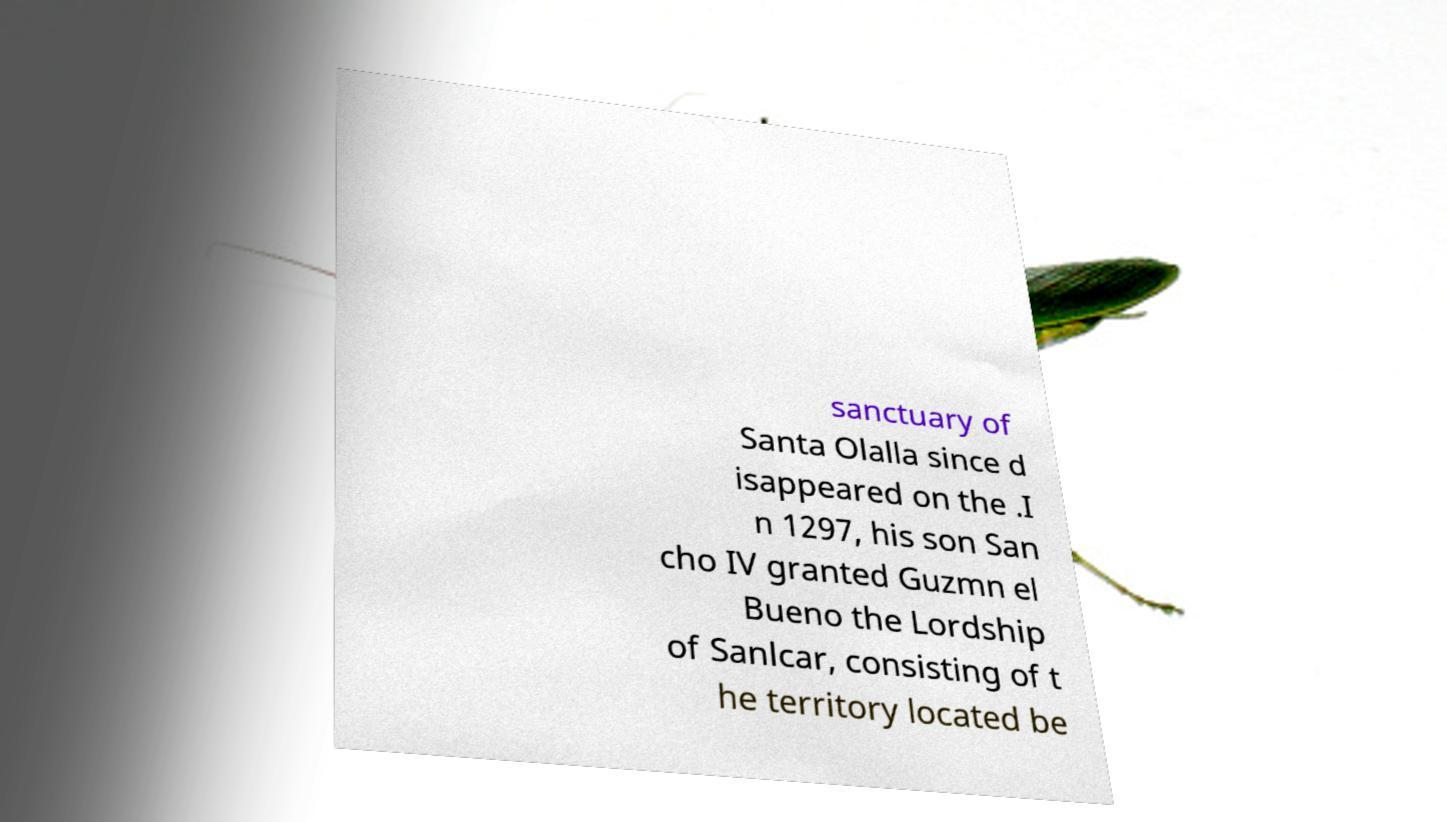Please read and relay the text visible in this image. What does it say? sanctuary of Santa Olalla since d isappeared on the .I n 1297, his son San cho IV granted Guzmn el Bueno the Lordship of Sanlcar, consisting of t he territory located be 